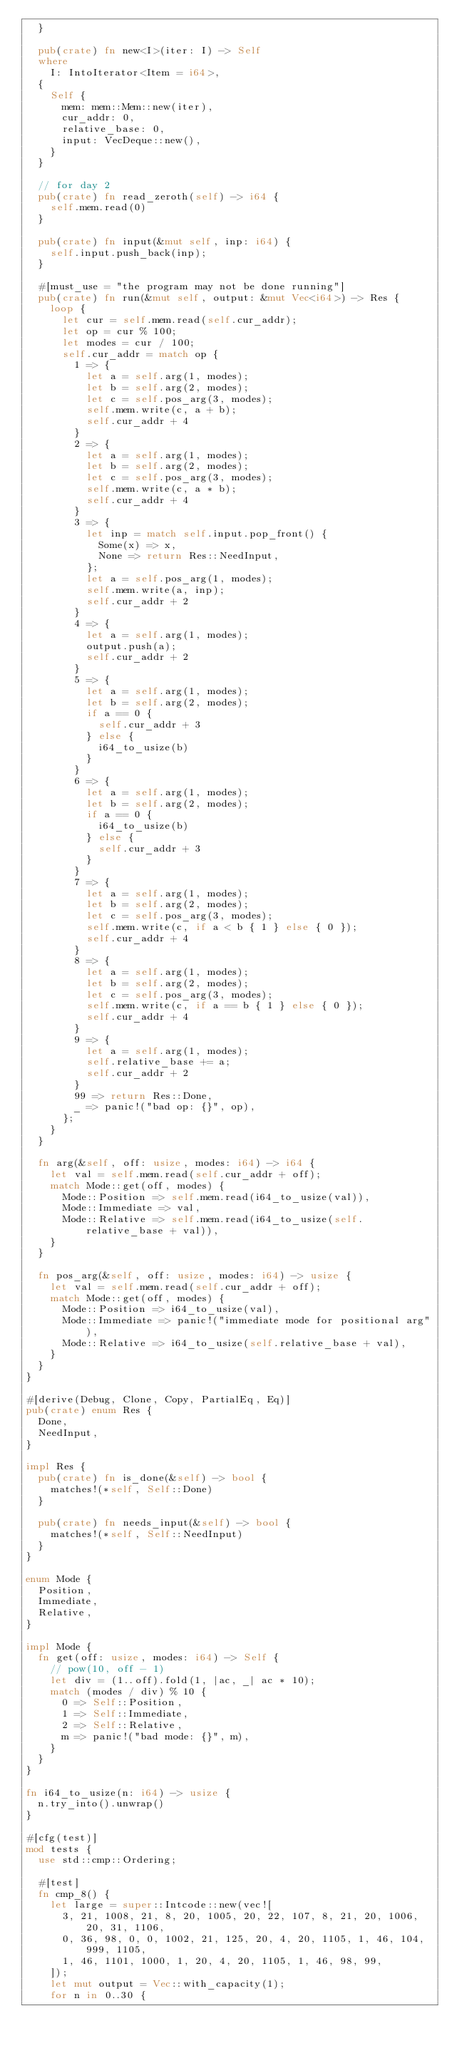Convert code to text. <code><loc_0><loc_0><loc_500><loc_500><_Rust_>  }

  pub(crate) fn new<I>(iter: I) -> Self
  where
    I: IntoIterator<Item = i64>,
  {
    Self {
      mem: mem::Mem::new(iter),
      cur_addr: 0,
      relative_base: 0,
      input: VecDeque::new(),
    }
  }

  // for day 2
  pub(crate) fn read_zeroth(self) -> i64 {
    self.mem.read(0)
  }

  pub(crate) fn input(&mut self, inp: i64) {
    self.input.push_back(inp);
  }

  #[must_use = "the program may not be done running"]
  pub(crate) fn run(&mut self, output: &mut Vec<i64>) -> Res {
    loop {
      let cur = self.mem.read(self.cur_addr);
      let op = cur % 100;
      let modes = cur / 100;
      self.cur_addr = match op {
        1 => {
          let a = self.arg(1, modes);
          let b = self.arg(2, modes);
          let c = self.pos_arg(3, modes);
          self.mem.write(c, a + b);
          self.cur_addr + 4
        }
        2 => {
          let a = self.arg(1, modes);
          let b = self.arg(2, modes);
          let c = self.pos_arg(3, modes);
          self.mem.write(c, a * b);
          self.cur_addr + 4
        }
        3 => {
          let inp = match self.input.pop_front() {
            Some(x) => x,
            None => return Res::NeedInput,
          };
          let a = self.pos_arg(1, modes);
          self.mem.write(a, inp);
          self.cur_addr + 2
        }
        4 => {
          let a = self.arg(1, modes);
          output.push(a);
          self.cur_addr + 2
        }
        5 => {
          let a = self.arg(1, modes);
          let b = self.arg(2, modes);
          if a == 0 {
            self.cur_addr + 3
          } else {
            i64_to_usize(b)
          }
        }
        6 => {
          let a = self.arg(1, modes);
          let b = self.arg(2, modes);
          if a == 0 {
            i64_to_usize(b)
          } else {
            self.cur_addr + 3
          }
        }
        7 => {
          let a = self.arg(1, modes);
          let b = self.arg(2, modes);
          let c = self.pos_arg(3, modes);
          self.mem.write(c, if a < b { 1 } else { 0 });
          self.cur_addr + 4
        }
        8 => {
          let a = self.arg(1, modes);
          let b = self.arg(2, modes);
          let c = self.pos_arg(3, modes);
          self.mem.write(c, if a == b { 1 } else { 0 });
          self.cur_addr + 4
        }
        9 => {
          let a = self.arg(1, modes);
          self.relative_base += a;
          self.cur_addr + 2
        }
        99 => return Res::Done,
        _ => panic!("bad op: {}", op),
      };
    }
  }

  fn arg(&self, off: usize, modes: i64) -> i64 {
    let val = self.mem.read(self.cur_addr + off);
    match Mode::get(off, modes) {
      Mode::Position => self.mem.read(i64_to_usize(val)),
      Mode::Immediate => val,
      Mode::Relative => self.mem.read(i64_to_usize(self.relative_base + val)),
    }
  }

  fn pos_arg(&self, off: usize, modes: i64) -> usize {
    let val = self.mem.read(self.cur_addr + off);
    match Mode::get(off, modes) {
      Mode::Position => i64_to_usize(val),
      Mode::Immediate => panic!("immediate mode for positional arg"),
      Mode::Relative => i64_to_usize(self.relative_base + val),
    }
  }
}

#[derive(Debug, Clone, Copy, PartialEq, Eq)]
pub(crate) enum Res {
  Done,
  NeedInput,
}

impl Res {
  pub(crate) fn is_done(&self) -> bool {
    matches!(*self, Self::Done)
  }

  pub(crate) fn needs_input(&self) -> bool {
    matches!(*self, Self::NeedInput)
  }
}

enum Mode {
  Position,
  Immediate,
  Relative,
}

impl Mode {
  fn get(off: usize, modes: i64) -> Self {
    // pow(10, off - 1)
    let div = (1..off).fold(1, |ac, _| ac * 10);
    match (modes / div) % 10 {
      0 => Self::Position,
      1 => Self::Immediate,
      2 => Self::Relative,
      m => panic!("bad mode: {}", m),
    }
  }
}

fn i64_to_usize(n: i64) -> usize {
  n.try_into().unwrap()
}

#[cfg(test)]
mod tests {
  use std::cmp::Ordering;

  #[test]
  fn cmp_8() {
    let large = super::Intcode::new(vec![
      3, 21, 1008, 21, 8, 20, 1005, 20, 22, 107, 8, 21, 20, 1006, 20, 31, 1106,
      0, 36, 98, 0, 0, 1002, 21, 125, 20, 4, 20, 1105, 1, 46, 104, 999, 1105,
      1, 46, 1101, 1000, 1, 20, 4, 20, 1105, 1, 46, 98, 99,
    ]);
    let mut output = Vec::with_capacity(1);
    for n in 0..30 {</code> 